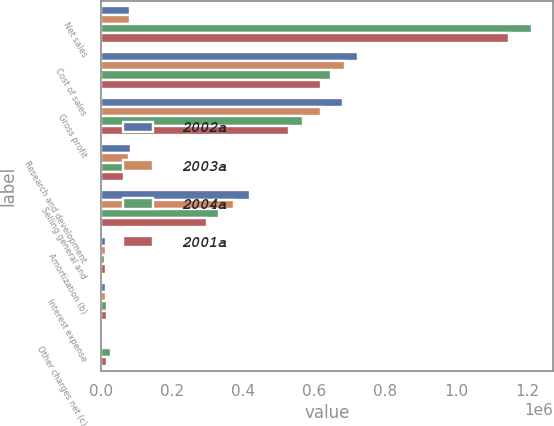<chart> <loc_0><loc_0><loc_500><loc_500><stacked_bar_chart><ecel><fcel>Net sales<fcel>Cost of sales<fcel>Gross profit<fcel>Research and development<fcel>Selling general and<fcel>Amortization (b)<fcel>Interest expense<fcel>Other charges net (c)<nl><fcel>2002a<fcel>80610<fcel>722047<fcel>682407<fcel>83217<fcel>419780<fcel>12256<fcel>12888<fcel>42<nl><fcel>2003a<fcel>80610<fcel>686255<fcel>618176<fcel>78003<fcel>372822<fcel>11724<fcel>14153<fcel>4563<nl><fcel>2004a<fcel>1.21371e+06<fcel>645970<fcel>567737<fcel>70625<fcel>331959<fcel>9332<fcel>17209<fcel>28202<nl><fcel>2001a<fcel>1.14802e+06<fcel>619140<fcel>528882<fcel>64627<fcel>299191<fcel>14114<fcel>17162<fcel>15354<nl></chart> 